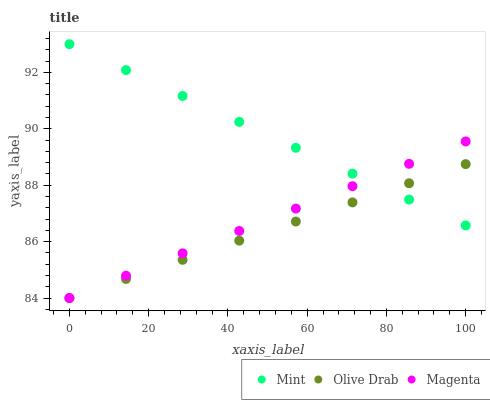Does Olive Drab have the minimum area under the curve?
Answer yes or no. Yes. Does Mint have the maximum area under the curve?
Answer yes or no. Yes. Does Mint have the minimum area under the curve?
Answer yes or no. No. Does Olive Drab have the maximum area under the curve?
Answer yes or no. No. Is Magenta the smoothest?
Answer yes or no. Yes. Is Olive Drab the roughest?
Answer yes or no. Yes. Is Mint the smoothest?
Answer yes or no. No. Is Mint the roughest?
Answer yes or no. No. Does Magenta have the lowest value?
Answer yes or no. Yes. Does Mint have the lowest value?
Answer yes or no. No. Does Mint have the highest value?
Answer yes or no. Yes. Does Olive Drab have the highest value?
Answer yes or no. No. Does Mint intersect Olive Drab?
Answer yes or no. Yes. Is Mint less than Olive Drab?
Answer yes or no. No. Is Mint greater than Olive Drab?
Answer yes or no. No. 